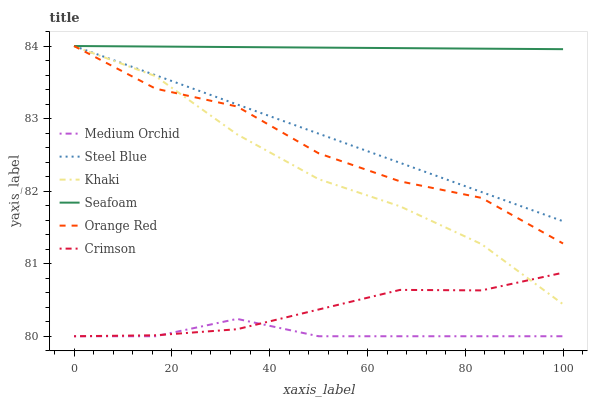Does Medium Orchid have the minimum area under the curve?
Answer yes or no. Yes. Does Seafoam have the maximum area under the curve?
Answer yes or no. Yes. Does Steel Blue have the minimum area under the curve?
Answer yes or no. No. Does Steel Blue have the maximum area under the curve?
Answer yes or no. No. Is Seafoam the smoothest?
Answer yes or no. Yes. Is Orange Red the roughest?
Answer yes or no. Yes. Is Medium Orchid the smoothest?
Answer yes or no. No. Is Medium Orchid the roughest?
Answer yes or no. No. Does Medium Orchid have the lowest value?
Answer yes or no. Yes. Does Steel Blue have the lowest value?
Answer yes or no. No. Does Orange Red have the highest value?
Answer yes or no. Yes. Does Medium Orchid have the highest value?
Answer yes or no. No. Is Medium Orchid less than Steel Blue?
Answer yes or no. Yes. Is Seafoam greater than Khaki?
Answer yes or no. Yes. Does Steel Blue intersect Orange Red?
Answer yes or no. Yes. Is Steel Blue less than Orange Red?
Answer yes or no. No. Is Steel Blue greater than Orange Red?
Answer yes or no. No. Does Medium Orchid intersect Steel Blue?
Answer yes or no. No. 